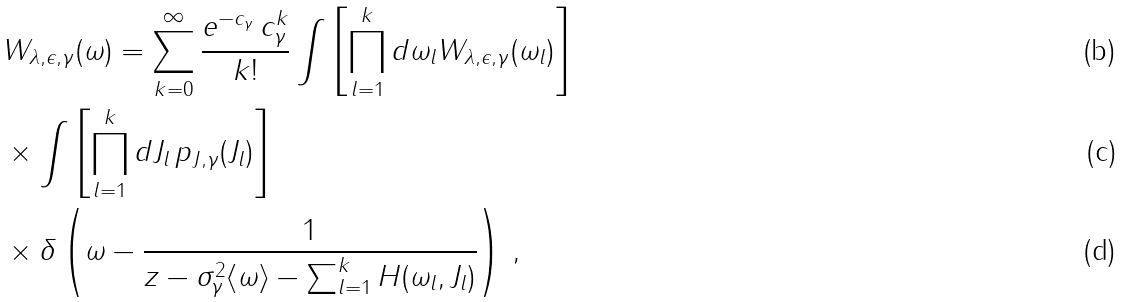<formula> <loc_0><loc_0><loc_500><loc_500>& W _ { \lambda , \epsilon , \gamma } ( \omega ) = \sum _ { k = 0 } ^ { \infty } \frac { e ^ { - c _ { \gamma } } \, c _ { \gamma } ^ { k } } { k ! } \int \left [ \prod _ { l = 1 } ^ { k } d \omega _ { l } W _ { \lambda , \epsilon , \gamma } ( \omega _ { l } ) \right ] \\ & \times \int \left [ \prod _ { l = 1 } ^ { k } d J _ { l } \, p _ { J , \gamma } ( J _ { l } ) \right ] \\ & \times \delta \left ( \omega - \frac { 1 } { z - \sigma _ { \gamma } ^ { 2 } \langle \omega \rangle - \sum _ { l = 1 } ^ { k } H ( \omega _ { l } , J _ { l } ) } \right ) \, ,</formula> 